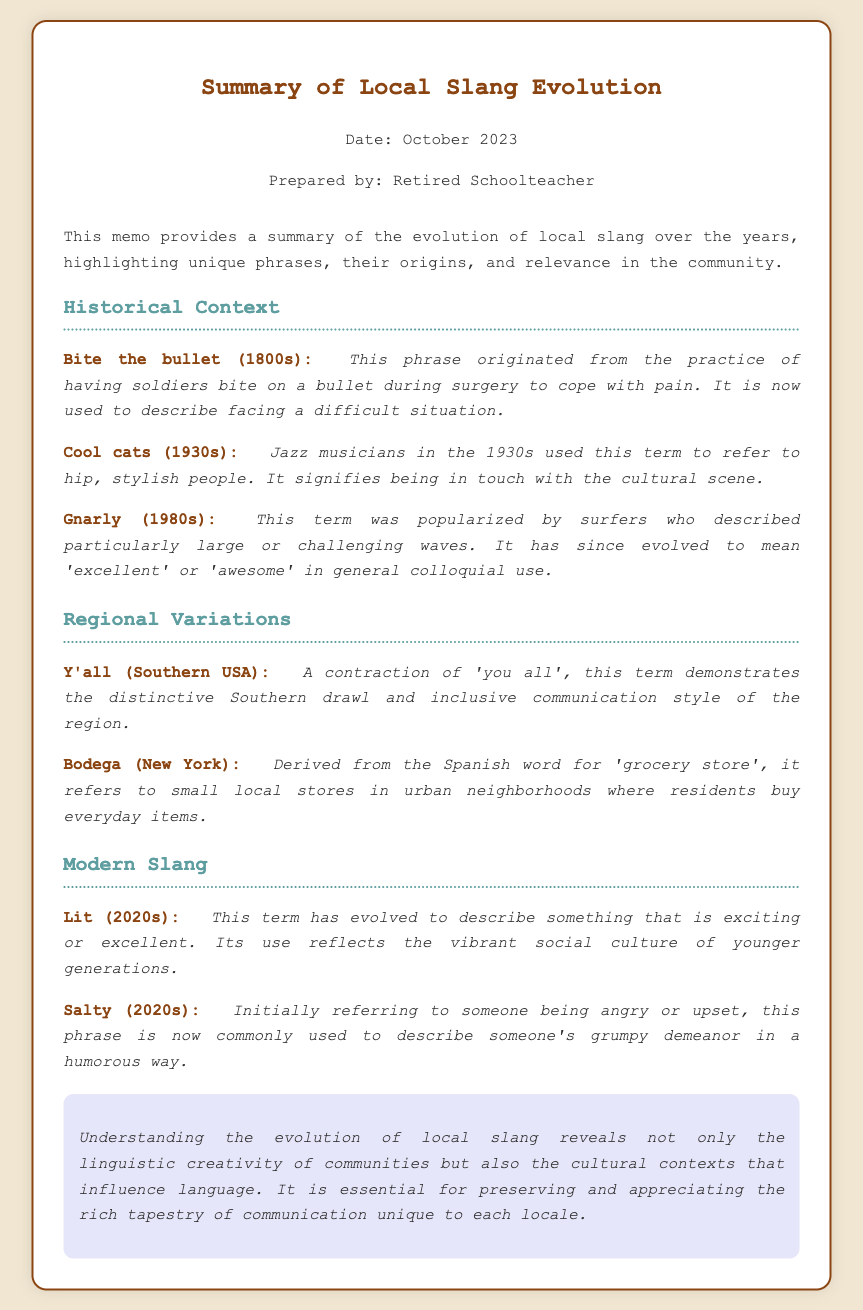What is the title of the memo? The title is found at the top of the document, indicating the memo's focus.
Answer: Summary of Local Slang Evolution Who prepared the memo? The author's name is provided in the header, indicating who prepared the document.
Answer: Retired Schoolteacher In what decade did "Cool cats" originate? The specific decade is mentioned alongside the origin of the phrase, providing the context of its use.
Answer: 1930s What is the origin of the term "Bodega"? The origin of the term is explained right after the phrase, detailing its roots.
Answer: Spanish What does "Lit" mean in modern slang? The current interpretation of the term is provided in the document.
Answer: exciting Which phrase originated from a practice during surgery? The document states this phrase's origin, linking it to a historical context.
Answer: Bite the bullet What does "Y'all" signify? The explanation following the phrase describes its meaning in context.
Answer: inclusive communication style In which region is "Bodega" commonly used? The document specifies the location where this term is primarily used, offering geographical context.
Answer: New York What cultural aspect does the memo highlight? The memo discusses the broader implications of slang regarding community and culture.
Answer: linguistic creativity 